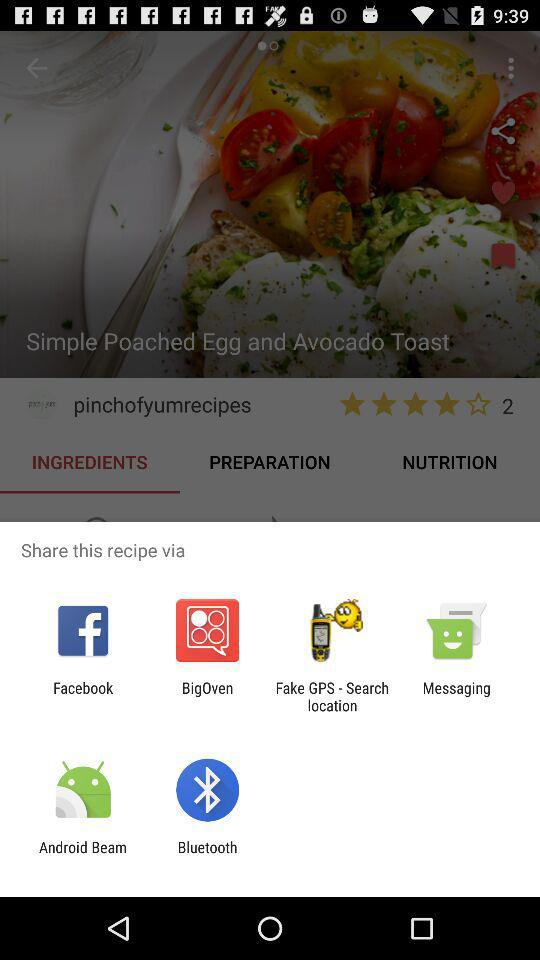Which options are given for sharing the recipe? The given options are "Facebook", "BigOven", "Fake GPS - Search location", "Messaging", "Android Beam" and "Bluetooth". 